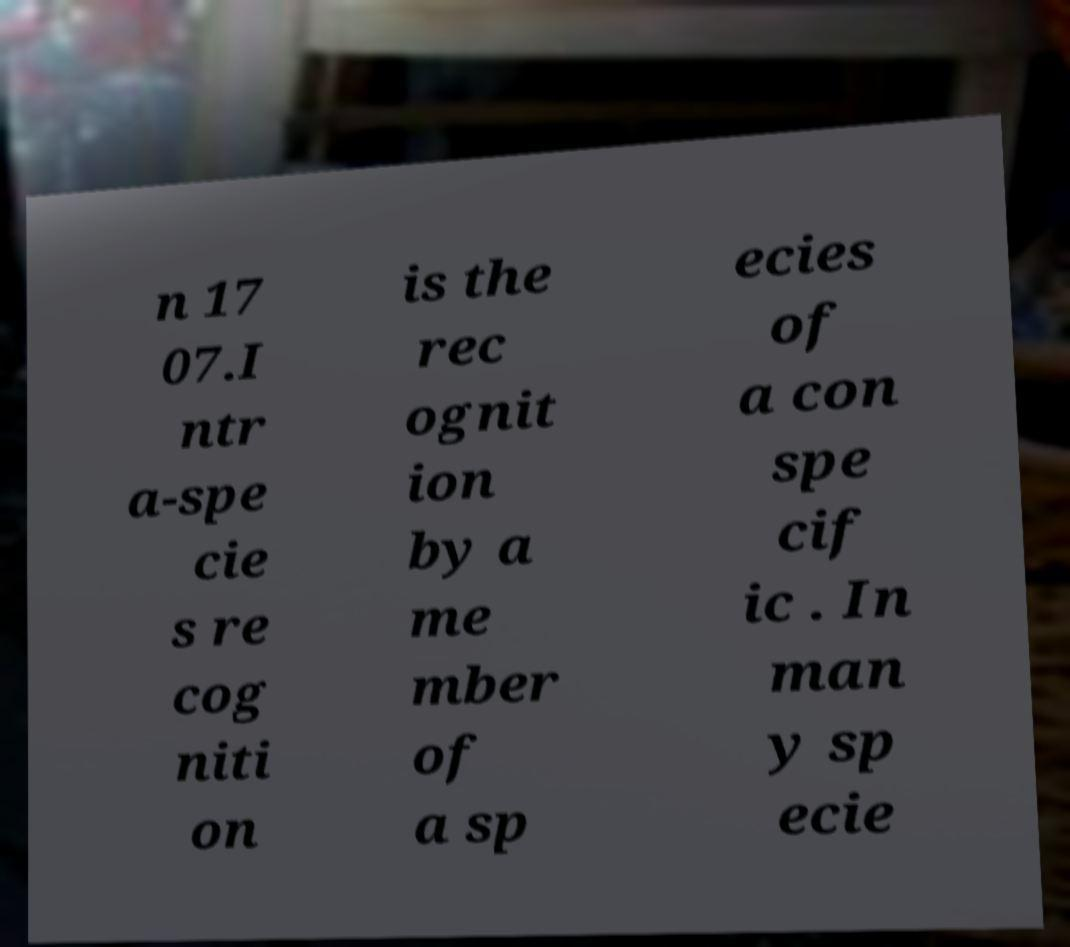What messages or text are displayed in this image? I need them in a readable, typed format. n 17 07.I ntr a-spe cie s re cog niti on is the rec ognit ion by a me mber of a sp ecies of a con spe cif ic . In man y sp ecie 